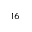<formula> <loc_0><loc_0><loc_500><loc_500>^ { 1 6 }</formula> 